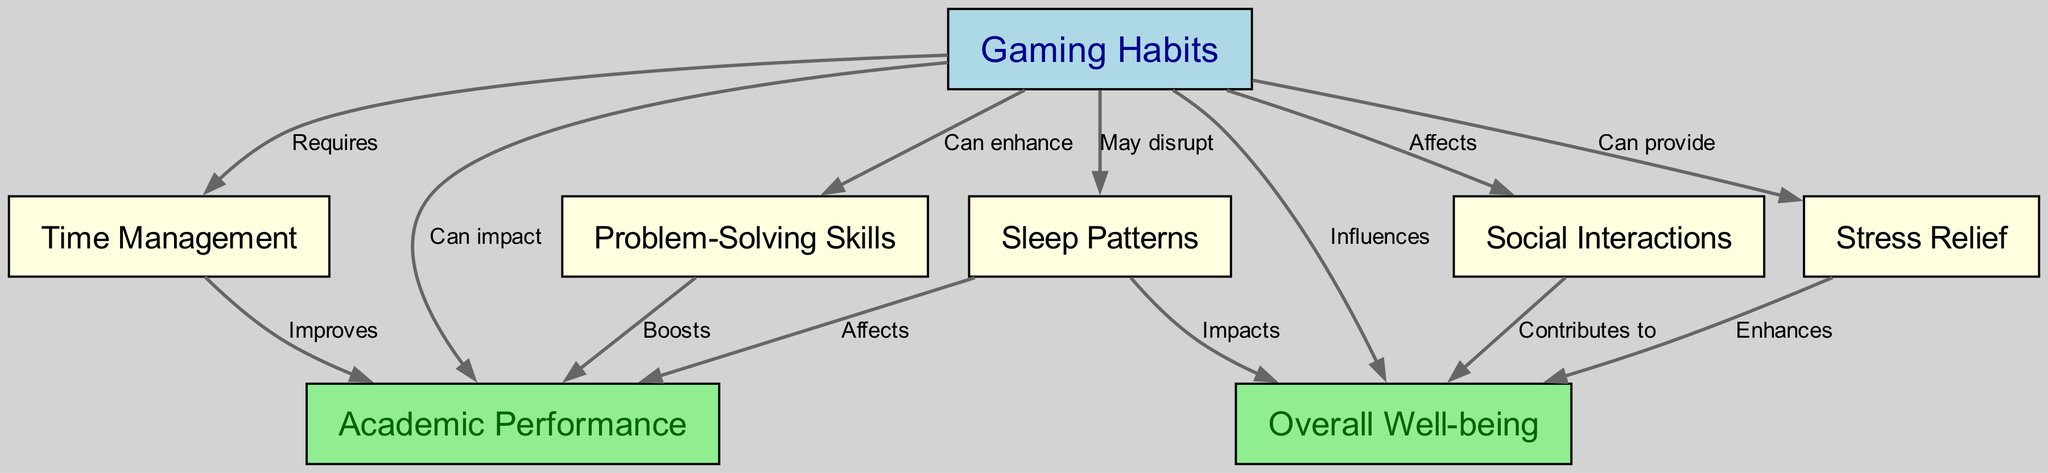What is the total number of nodes in the diagram? The diagram contains nodes representing various aspects related to gaming habits, academic performance, and overall well-being. By counting each unique node listed under the "nodes" section of the data, we find a total of 8 nodes.
Answer: 8 Which node is influenced by "Gaming Habits"? From the diagram, we observe that "Overall Well-being" is a node that is influenced by "Gaming Habits." This relationship is indicated by the directed edge from "Gaming Habits" to "Overall Well-being" labeled as "Influences."
Answer: Overall Well-being How many edges are there in the diagram? The edges represent the various relationships between the nodes. By counting the connections made in the "edges" section, we find there are a total of 12 edges in the diagram.
Answer: 12 What are the impacts of "Gaming Habits" on "Sleep Patterns"? There is a directed edge from "Gaming Habits" to "Sleep Patterns" marked as "May disrupt," indicating a negative impact of gaming habits on sleep patterns.
Answer: May disrupt If "Time Management" improves "Academic Performance," what influences "Overall Well-being"? "Overall Well-being" is influenced by several nodes, including "Social Interactions," which contributes to it, and "Stress Relief," which enhances it. To combine this information, we look for the specific influences noted in the diagram and see multiple relationships contribute to overall well-being.
Answer: Social Interactions and Stress Relief Which node can enhance "Problem-Solving Skills"? The diagram mentions that "Gaming Habits" can enhance "Problem-Solving Skills." This is indicated by the directed edge from "Gaming Habits" to "Problem-Solving Skills," labeled as "Can enhance."
Answer: Gaming Habits What effect does "Sleep Patterns" have on "Academic Performance"? The diagram indicates that there is an edge leading from "Sleep Patterns" to "Academic Performance," with the label "Affects," suggesting that sleep patterns can negatively impact academic performance.
Answer: Affects Which two nodes are connected by the label "Boosts"? The "Problem-Solving Skills" node and "Academic Performance" node are connected by the edge labeled "Boosts," indicating that better problem-solving skills can lead to improved academic performance.
Answer: Problem-Solving Skills and Academic Performance 